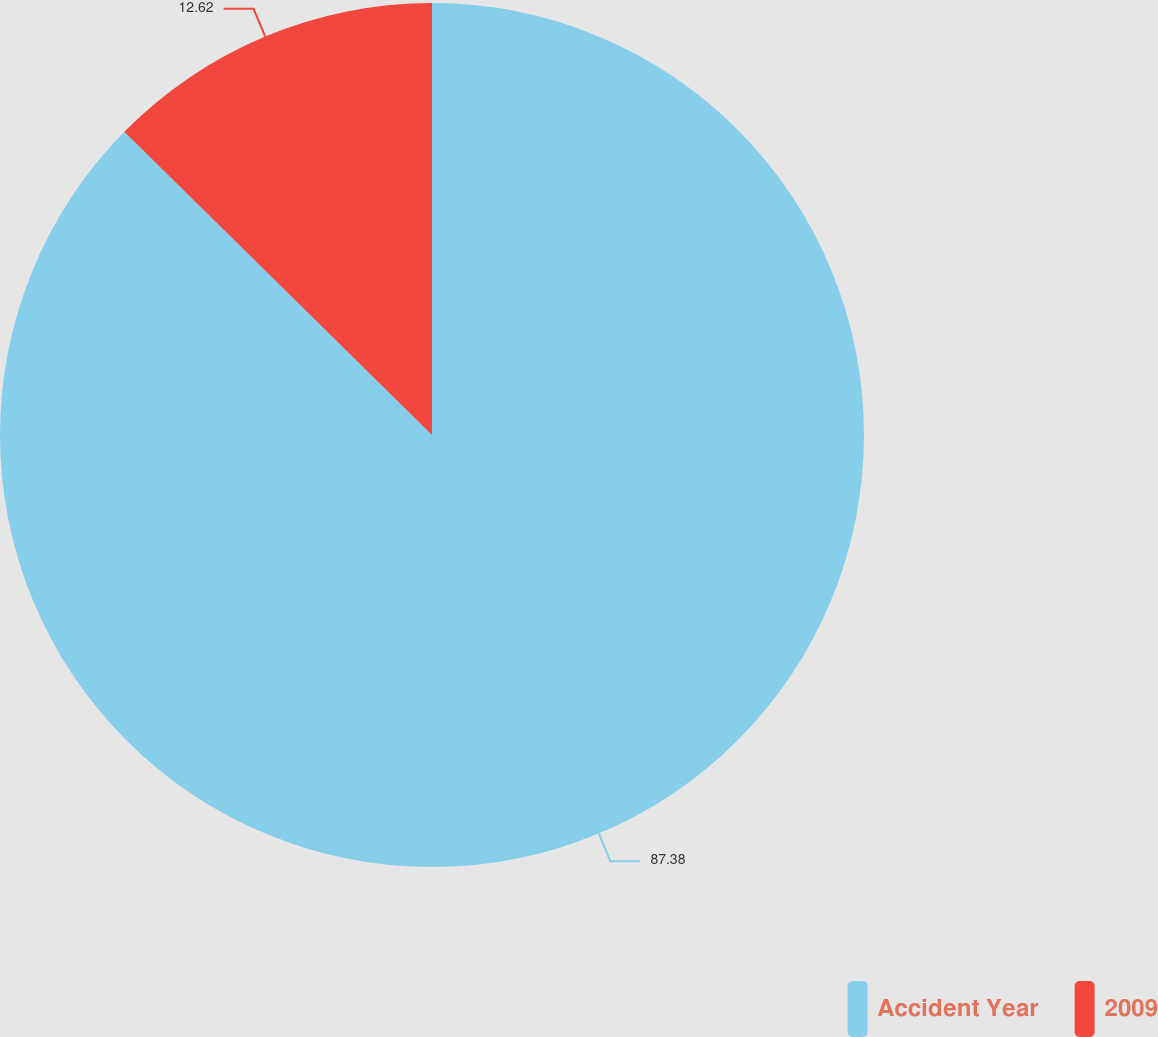Convert chart to OTSL. <chart><loc_0><loc_0><loc_500><loc_500><pie_chart><fcel>Accident Year<fcel>2009<nl><fcel>87.38%<fcel>12.62%<nl></chart> 